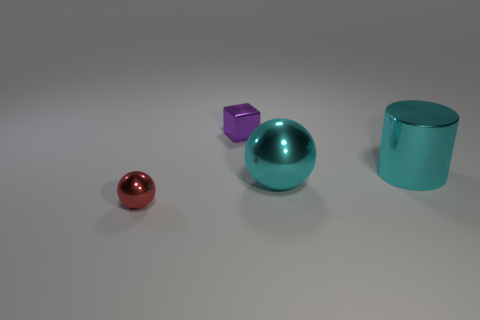Can you describe the colors and the mood they create in this image? The image features a palette of cool tones, with a cyan ball, a purple cube, and a teal cylinder dominating the view. These colors evoke a calm and modern atmosphere. The use of gentle lighting and a soft shadow cast creates a serene and almost surreal environment, potentially conveying a sense of tranquility or innovation. 